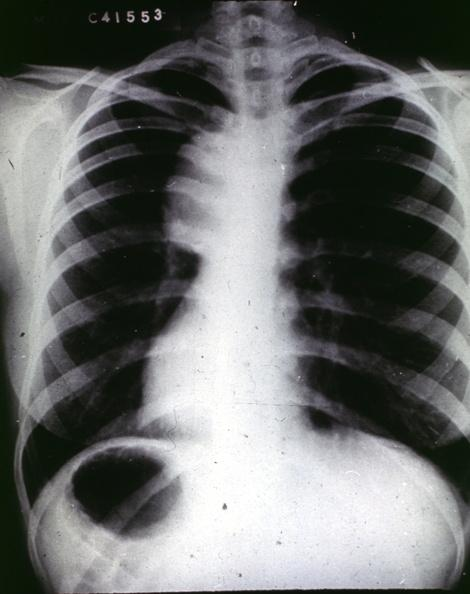does vasculature show traumatic aneurysm aortogram?
Answer the question using a single word or phrase. No 